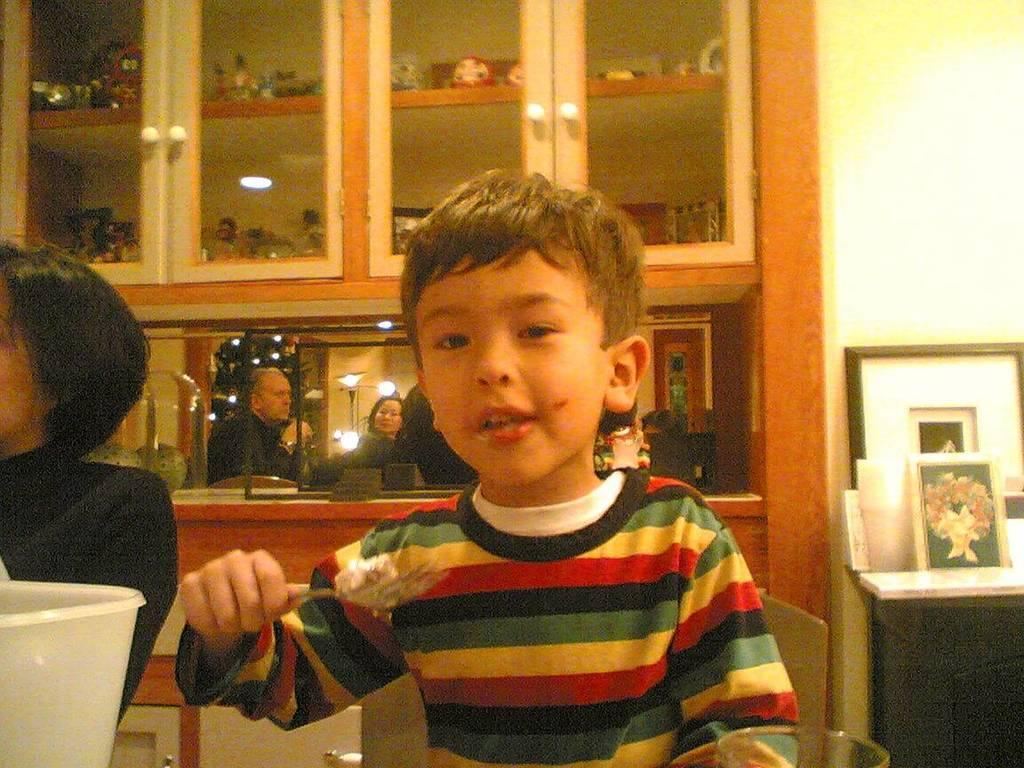What is the main subject of the image? The main subject of the image is a kid. What is the kid doing in the image? The kid is eating food in the image. Can you describe the background of the image? In the background of the image, there are cupboards, a wall, frames, toys, lights, and a glass object. How many other persons are present in the image? There are other persons present in the image, but the exact number is not specified. What type of lead can be seen in the mouth of the kid in the image? There is no lead present in the image, and the kid's mouth is not visible. What kind of crack is visible on the glass object in the background of the image? There is no crack visible on the glass object in the background of the image. 